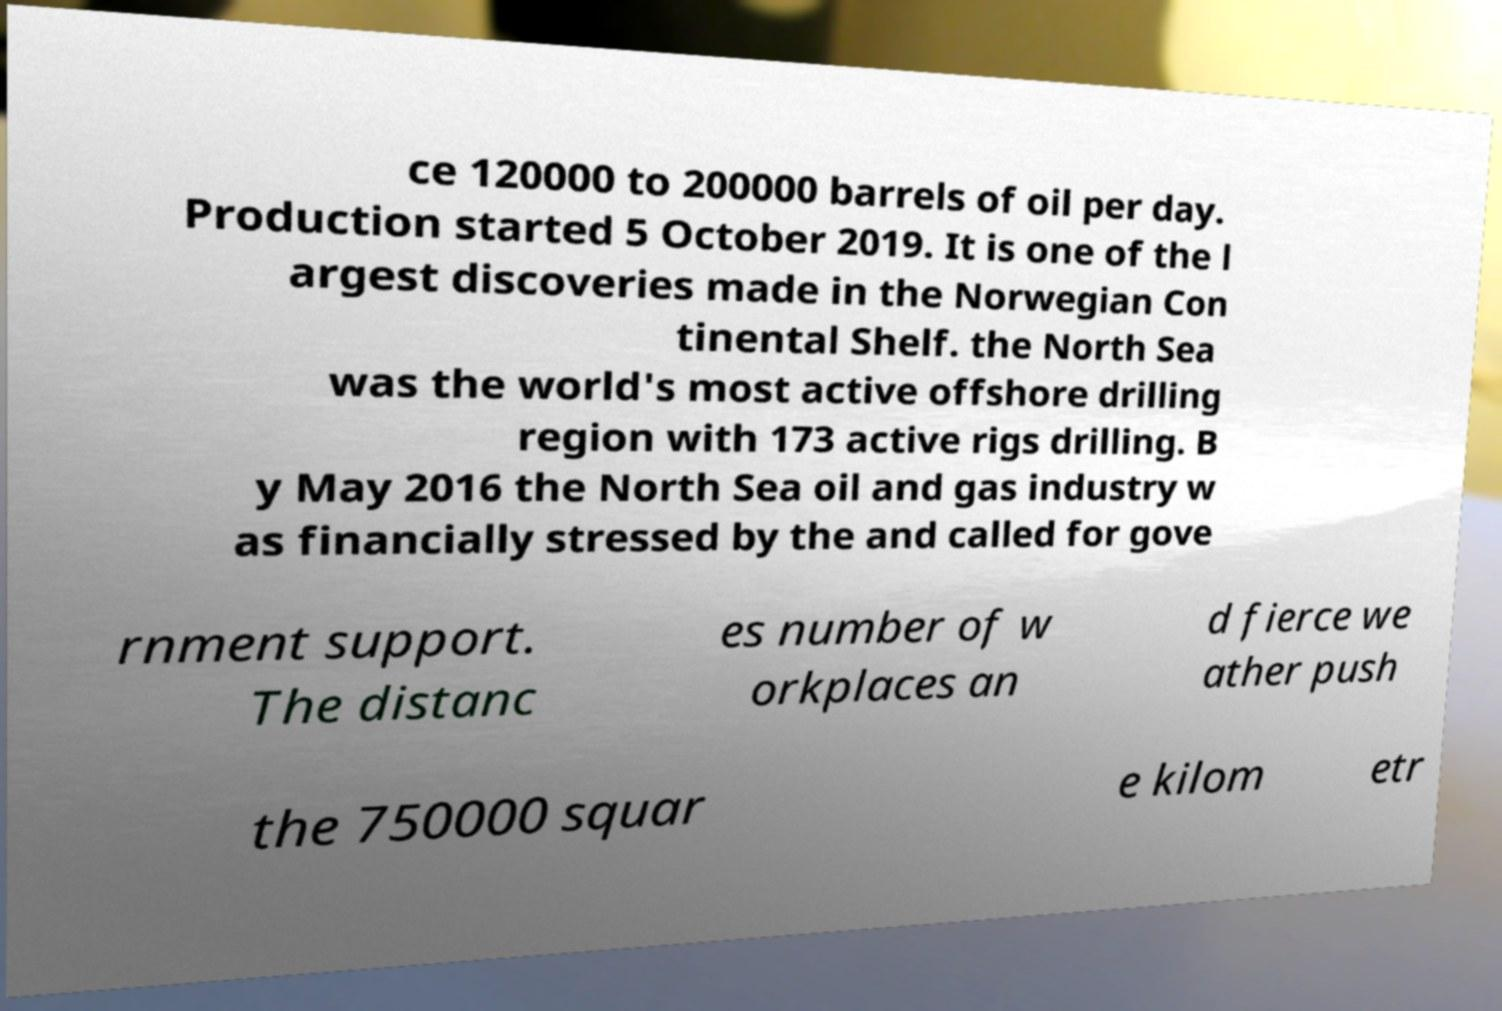There's text embedded in this image that I need extracted. Can you transcribe it verbatim? ce 120000 to 200000 barrels of oil per day. Production started 5 October 2019. It is one of the l argest discoveries made in the Norwegian Con tinental Shelf. the North Sea was the world's most active offshore drilling region with 173 active rigs drilling. B y May 2016 the North Sea oil and gas industry w as financially stressed by the and called for gove rnment support. The distanc es number of w orkplaces an d fierce we ather push the 750000 squar e kilom etr 